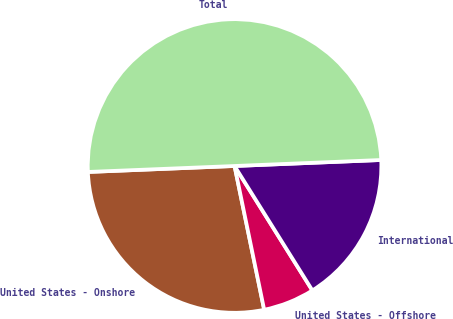Convert chart to OTSL. <chart><loc_0><loc_0><loc_500><loc_500><pie_chart><fcel>United States - Onshore<fcel>United States - Offshore<fcel>International<fcel>Total<nl><fcel>27.59%<fcel>5.66%<fcel>16.76%<fcel>50.0%<nl></chart> 